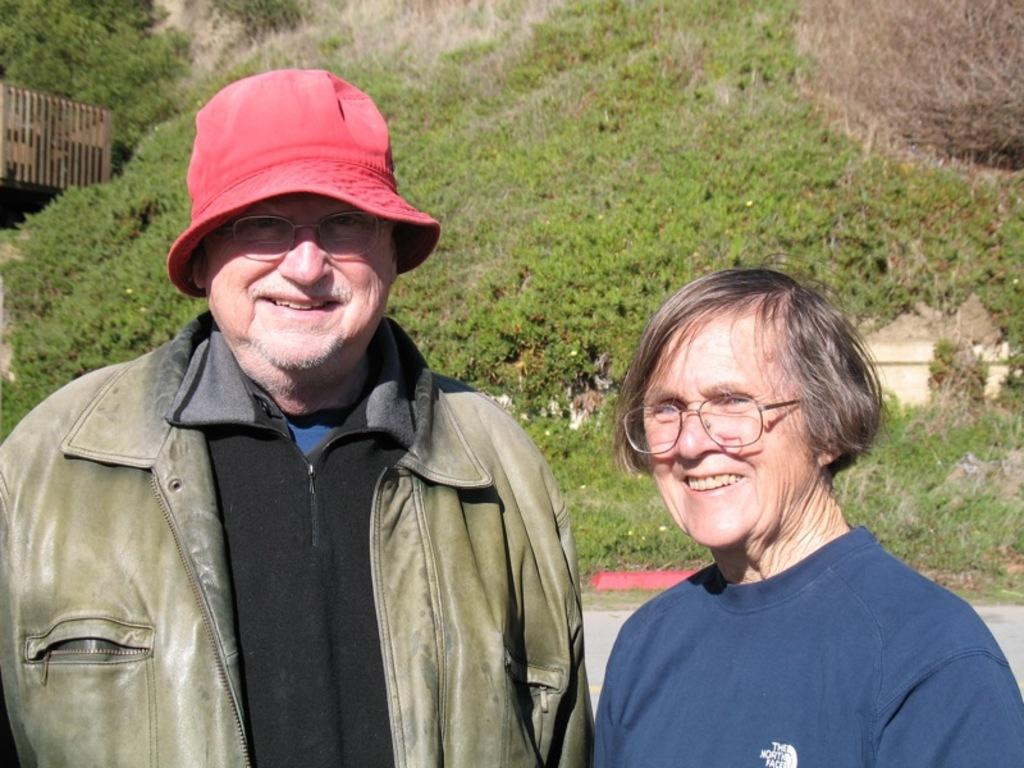Who can be seen in the foreground of the image? There is a man and a woman in the foreground of the image. What are the man and woman doing in the image? The man and woman are standing and smiling. What can be seen in the background of the image? There are mountains, trees, and grass in the background of the image. What type of haircut does the man have in the image? There is no information about the man's haircut in the image. What is the man's reaction to the top in the image? There is no top or any clothing mentioned in the image, so it is not possible to determine the man's reaction to it. 